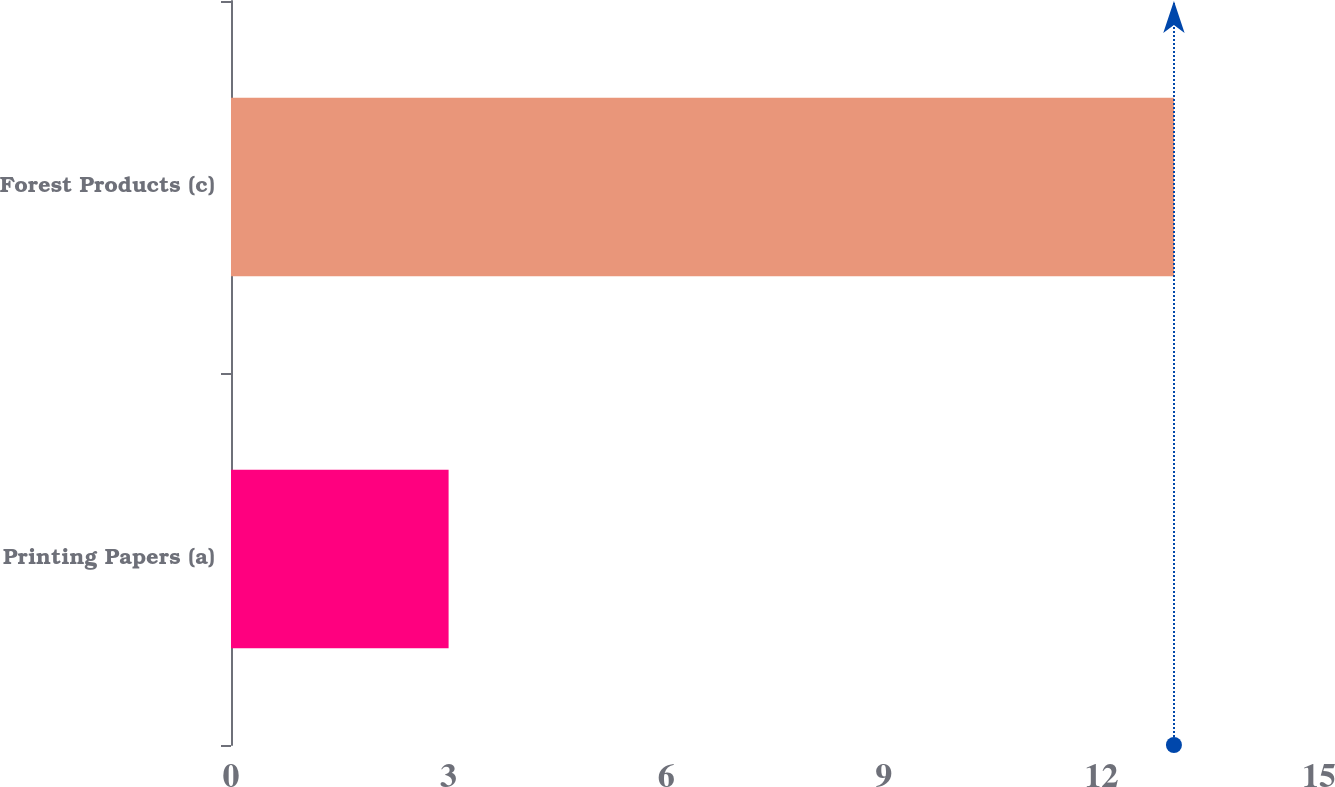<chart> <loc_0><loc_0><loc_500><loc_500><bar_chart><fcel>Printing Papers (a)<fcel>Forest Products (c)<nl><fcel>3<fcel>13<nl></chart> 